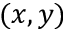<formula> <loc_0><loc_0><loc_500><loc_500>( x , y )</formula> 